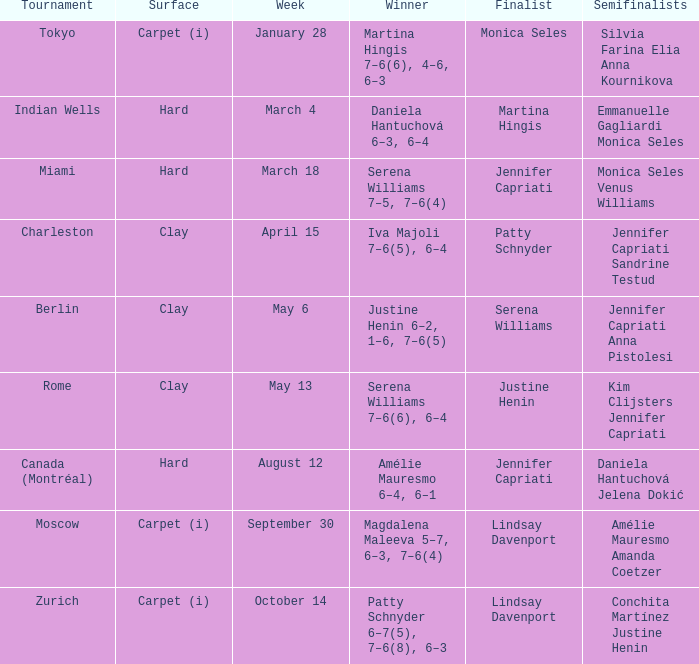What was the surface for finalist Justine Henin? Clay. Can you give me this table as a dict? {'header': ['Tournament', 'Surface', 'Week', 'Winner', 'Finalist', 'Semifinalists'], 'rows': [['Tokyo', 'Carpet (i)', 'January 28', 'Martina Hingis 7–6(6), 4–6, 6–3', 'Monica Seles', 'Silvia Farina Elia Anna Kournikova'], ['Indian Wells', 'Hard', 'March 4', 'Daniela Hantuchová 6–3, 6–4', 'Martina Hingis', 'Emmanuelle Gagliardi Monica Seles'], ['Miami', 'Hard', 'March 18', 'Serena Williams 7–5, 7–6(4)', 'Jennifer Capriati', 'Monica Seles Venus Williams'], ['Charleston', 'Clay', 'April 15', 'Iva Majoli 7–6(5), 6–4', 'Patty Schnyder', 'Jennifer Capriati Sandrine Testud'], ['Berlin', 'Clay', 'May 6', 'Justine Henin 6–2, 1–6, 7–6(5)', 'Serena Williams', 'Jennifer Capriati Anna Pistolesi'], ['Rome', 'Clay', 'May 13', 'Serena Williams 7–6(6), 6–4', 'Justine Henin', 'Kim Clijsters Jennifer Capriati'], ['Canada (Montréal)', 'Hard', 'August 12', 'Amélie Mauresmo 6–4, 6–1', 'Jennifer Capriati', 'Daniela Hantuchová Jelena Dokić'], ['Moscow', 'Carpet (i)', 'September 30', 'Magdalena Maleeva 5–7, 6–3, 7–6(4)', 'Lindsay Davenport', 'Amélie Mauresmo Amanda Coetzer'], ['Zurich', 'Carpet (i)', 'October 14', 'Patty Schnyder 6–7(5), 7–6(8), 6–3', 'Lindsay Davenport', 'Conchita Martínez Justine Henin']]} 